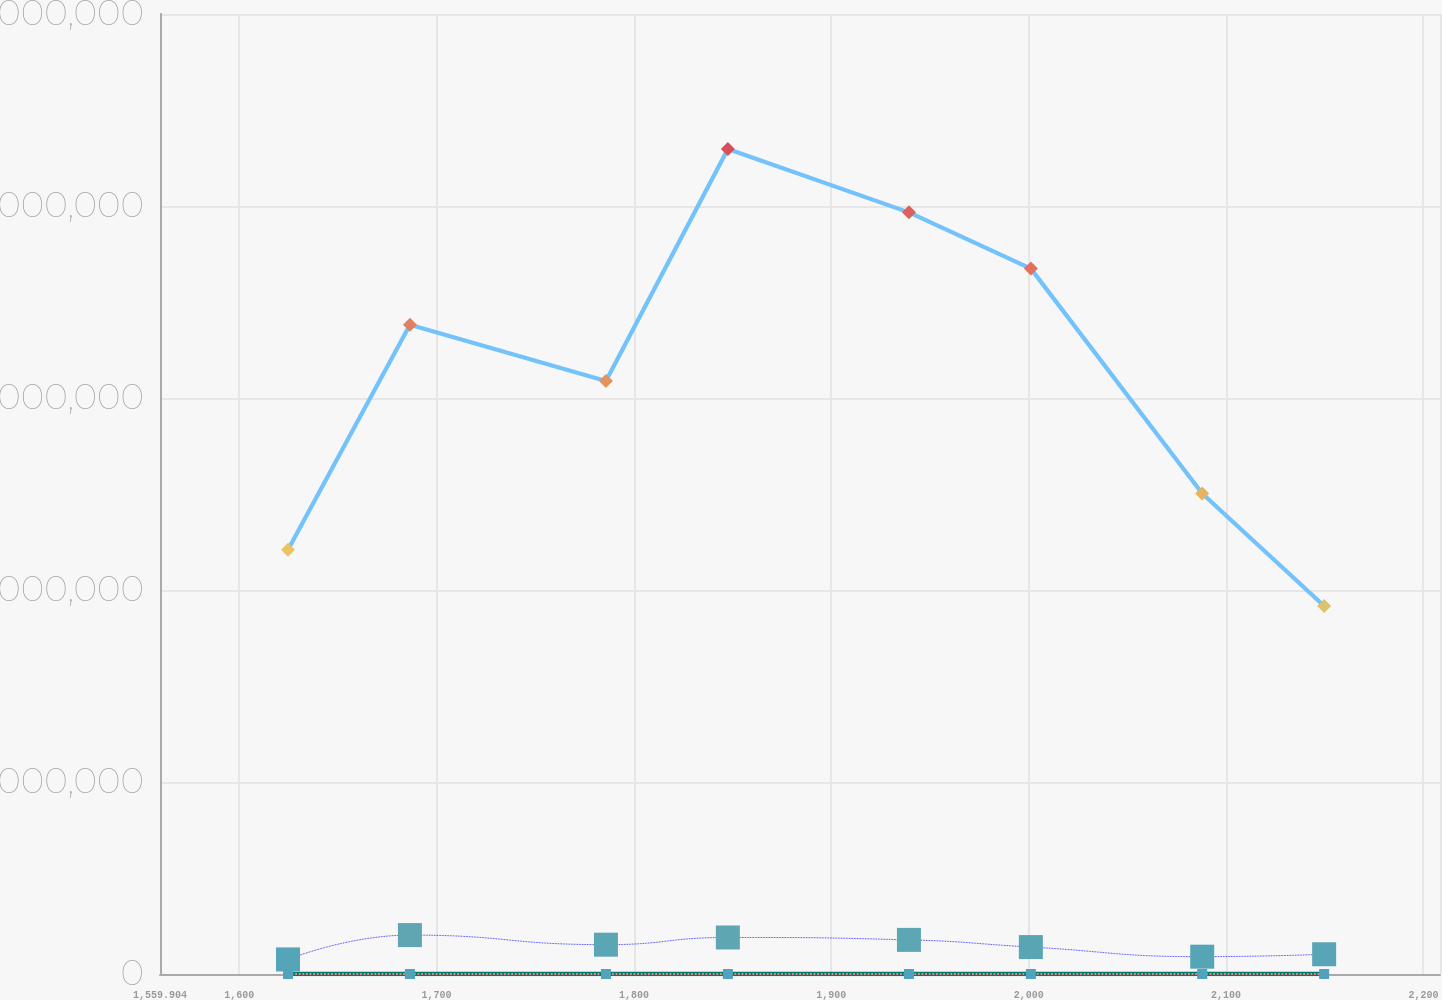Convert chart to OTSL. <chart><loc_0><loc_0><loc_500><loc_500><line_chart><ecel><fcel>Percentage of Leased Square Footage Expiring<fcel>Annualized Base Rent Represented by Expiring Leases<fcel>Leased Square Footage Expiring<fcel>Percentage of Annualized Base Rent Represented by Expiring Leases<nl><fcel>1624.75<fcel>758689<fcel>7.47<fcel>2.20942e+07<fcel>4.49<nl><fcel>1686.52<fcel>2.0265e+06<fcel>10.47<fcel>3.38103e+07<fcel>12.26<nl><fcel>1785.82<fcel>1.52725e+06<fcel>12.47<fcel>3.08813e+07<fcel>10.34<nl><fcel>1847.59<fcel>1.90154e+06<fcel>14.43<fcel>4.29655e+07<fcel>14.13<nl><fcel>1939.32<fcel>1.77658e+06<fcel>11.47<fcel>3.96684e+07<fcel>11.3<nl><fcel>2001.09<fcel>1.40229e+06<fcel>9.47<fcel>3.67393e+07<fcel>9.38<nl><fcel>2087.9<fcel>902460<fcel>8.47<fcel>2.50232e+07<fcel>8.33<nl><fcel>2149.67<fcel>1.02742e+06<fcel>4.47<fcel>1.91651e+07<fcel>6.41<nl><fcel>2211.44<fcel>1.27733e+06<fcel>5.47<fcel>2.79522e+07<fcel>7.37<nl><fcel>2273.21<fcel>1.15238e+06<fcel>6.47<fcel>1.36752e+07<fcel>5.45<nl></chart> 